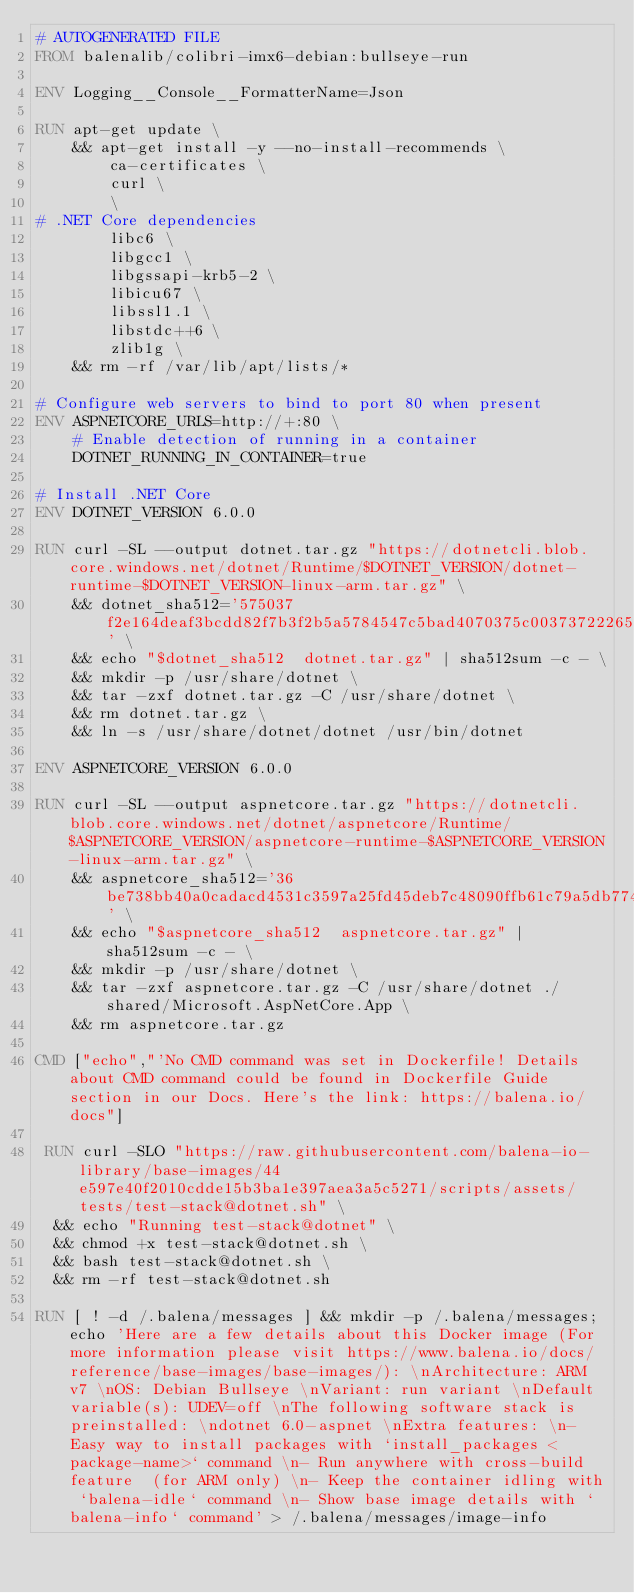Convert code to text. <code><loc_0><loc_0><loc_500><loc_500><_Dockerfile_># AUTOGENERATED FILE
FROM balenalib/colibri-imx6-debian:bullseye-run

ENV Logging__Console__FormatterName=Json

RUN apt-get update \
    && apt-get install -y --no-install-recommends \
        ca-certificates \
        curl \
        \
# .NET Core dependencies
        libc6 \
        libgcc1 \
        libgssapi-krb5-2 \
        libicu67 \
        libssl1.1 \
        libstdc++6 \
        zlib1g \
    && rm -rf /var/lib/apt/lists/*

# Configure web servers to bind to port 80 when present
ENV ASPNETCORE_URLS=http://+:80 \
    # Enable detection of running in a container
    DOTNET_RUNNING_IN_CONTAINER=true

# Install .NET Core
ENV DOTNET_VERSION 6.0.0

RUN curl -SL --output dotnet.tar.gz "https://dotnetcli.blob.core.windows.net/dotnet/Runtime/$DOTNET_VERSION/dotnet-runtime-$DOTNET_VERSION-linux-arm.tar.gz" \
    && dotnet_sha512='575037f2e164deaf3bcdd82f7b3f2b5a5784547c5bad4070375c00373722265401b88a81695b919f92ca176f21c1bdf1716f8fce16ab3d301ae666daa8cae750' \
    && echo "$dotnet_sha512  dotnet.tar.gz" | sha512sum -c - \
    && mkdir -p /usr/share/dotnet \
    && tar -zxf dotnet.tar.gz -C /usr/share/dotnet \
    && rm dotnet.tar.gz \
    && ln -s /usr/share/dotnet/dotnet /usr/bin/dotnet

ENV ASPNETCORE_VERSION 6.0.0

RUN curl -SL --output aspnetcore.tar.gz "https://dotnetcli.blob.core.windows.net/dotnet/aspnetcore/Runtime/$ASPNETCORE_VERSION/aspnetcore-runtime-$ASPNETCORE_VERSION-linux-arm.tar.gz" \
    && aspnetcore_sha512='36be738bb40a0cadacd4531c3597a25fd45deb7c48090ffb61c79a5db7742a5b8e13051b06556e15e7e162e4a044795c0ca5e6da4db26b63b05c37b39e74e301' \
    && echo "$aspnetcore_sha512  aspnetcore.tar.gz" | sha512sum -c - \
    && mkdir -p /usr/share/dotnet \
    && tar -zxf aspnetcore.tar.gz -C /usr/share/dotnet ./shared/Microsoft.AspNetCore.App \
    && rm aspnetcore.tar.gz

CMD ["echo","'No CMD command was set in Dockerfile! Details about CMD command could be found in Dockerfile Guide section in our Docs. Here's the link: https://balena.io/docs"]

 RUN curl -SLO "https://raw.githubusercontent.com/balena-io-library/base-images/44e597e40f2010cdde15b3ba1e397aea3a5c5271/scripts/assets/tests/test-stack@dotnet.sh" \
  && echo "Running test-stack@dotnet" \
  && chmod +x test-stack@dotnet.sh \
  && bash test-stack@dotnet.sh \
  && rm -rf test-stack@dotnet.sh 

RUN [ ! -d /.balena/messages ] && mkdir -p /.balena/messages; echo 'Here are a few details about this Docker image (For more information please visit https://www.balena.io/docs/reference/base-images/base-images/): \nArchitecture: ARM v7 \nOS: Debian Bullseye \nVariant: run variant \nDefault variable(s): UDEV=off \nThe following software stack is preinstalled: \ndotnet 6.0-aspnet \nExtra features: \n- Easy way to install packages with `install_packages <package-name>` command \n- Run anywhere with cross-build feature  (for ARM only) \n- Keep the container idling with `balena-idle` command \n- Show base image details with `balena-info` command' > /.balena/messages/image-info
</code> 